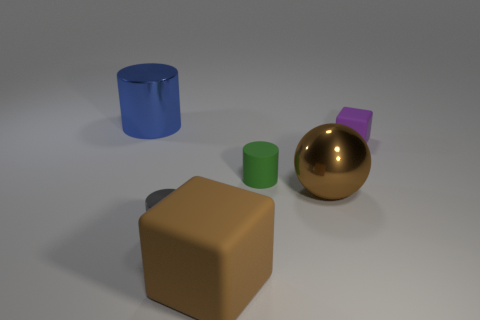How many objects are the same size as the matte cylinder?
Your response must be concise. 2. There is a cube in front of the green object; what number of gray metallic objects are on the left side of it?
Give a very brief answer. 1. There is a metallic cylinder to the right of the large metallic cylinder; does it have the same color as the big cube?
Your answer should be compact. No. There is a metal cylinder that is in front of the big metallic object that is to the left of the big brown rubber object; are there any small gray shiny cylinders that are right of it?
Provide a short and direct response. No. The big thing that is on the right side of the tiny gray thing and on the left side of the big metallic ball has what shape?
Your answer should be compact. Cube. Is there a thing that has the same color as the sphere?
Offer a very short reply. Yes. There is a large metal thing in front of the matte object behind the matte cylinder; what is its color?
Ensure brevity in your answer.  Brown. What size is the metallic cylinder to the right of the metal cylinder that is behind the shiny cylinder in front of the blue object?
Offer a terse response. Small. Do the big block and the small cylinder to the right of the gray cylinder have the same material?
Provide a short and direct response. Yes. The purple thing that is the same material as the green thing is what size?
Offer a very short reply. Small. 